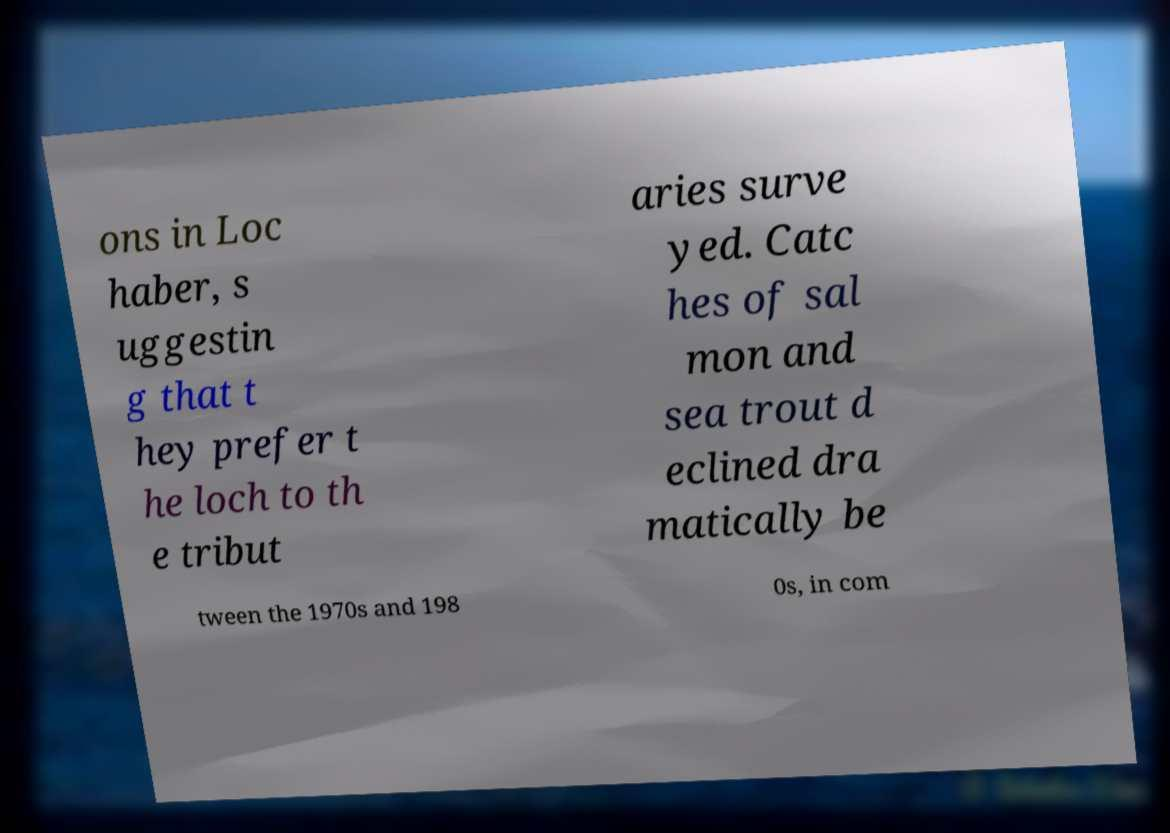Could you assist in decoding the text presented in this image and type it out clearly? ons in Loc haber, s uggestin g that t hey prefer t he loch to th e tribut aries surve yed. Catc hes of sal mon and sea trout d eclined dra matically be tween the 1970s and 198 0s, in com 